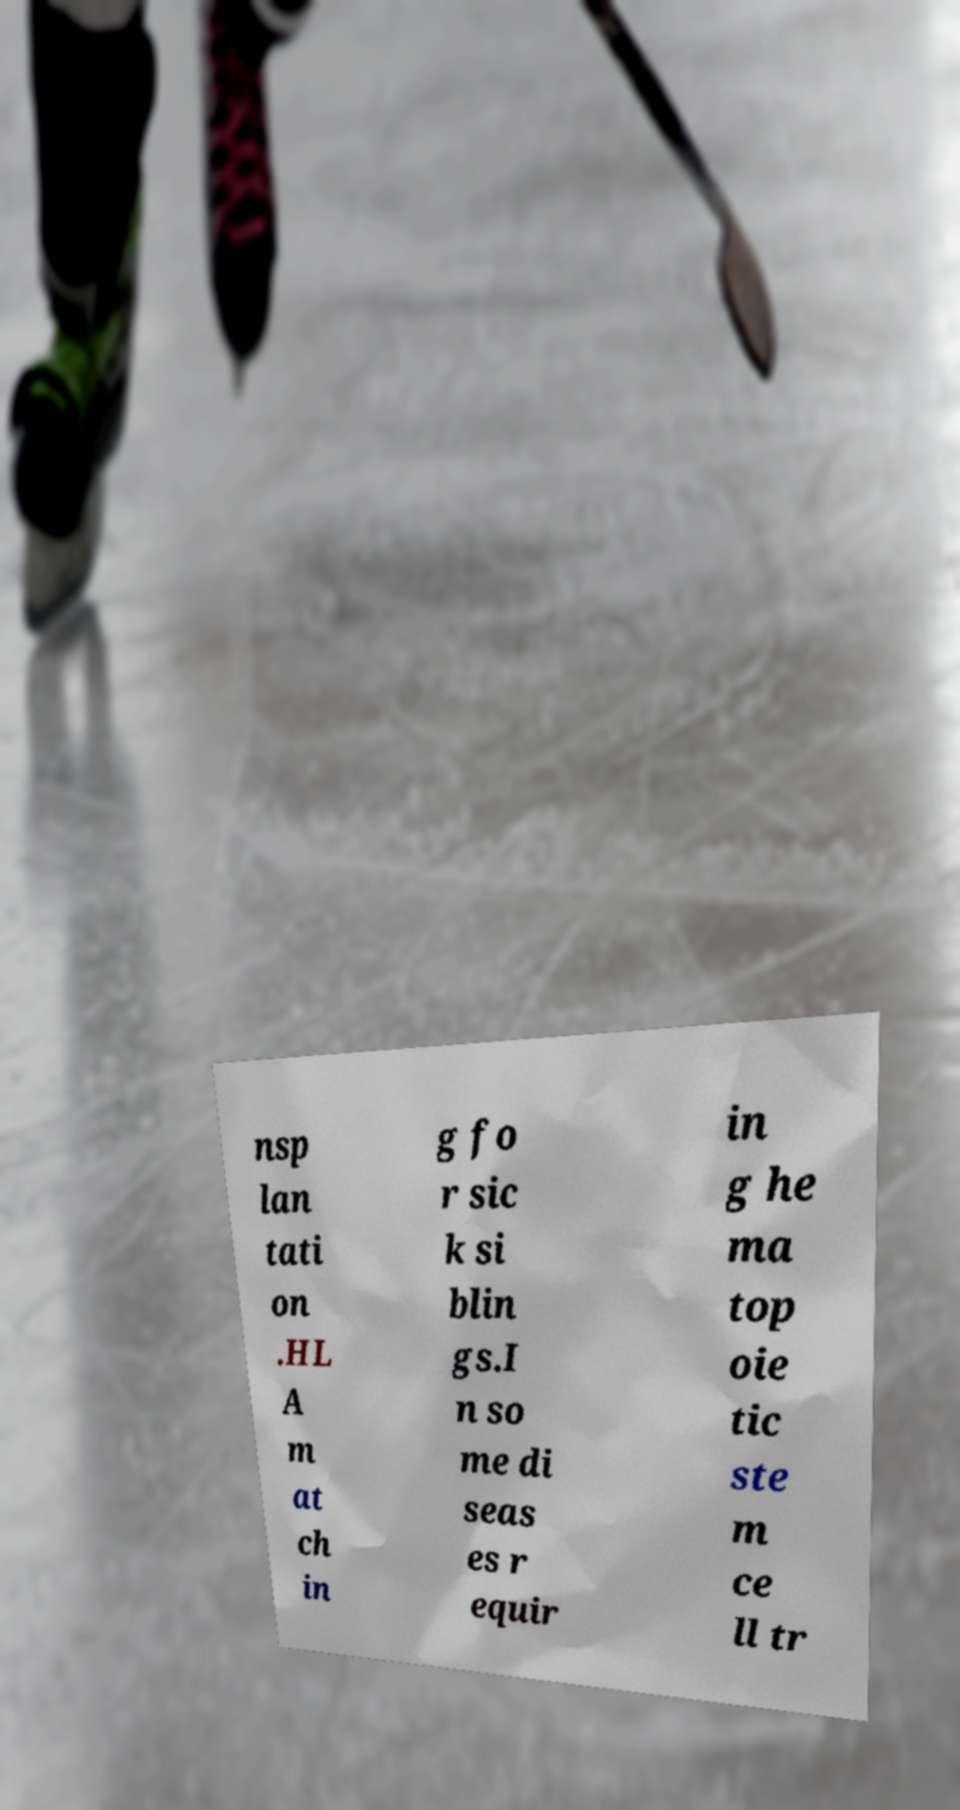Please read and relay the text visible in this image. What does it say? nsp lan tati on .HL A m at ch in g fo r sic k si blin gs.I n so me di seas es r equir in g he ma top oie tic ste m ce ll tr 